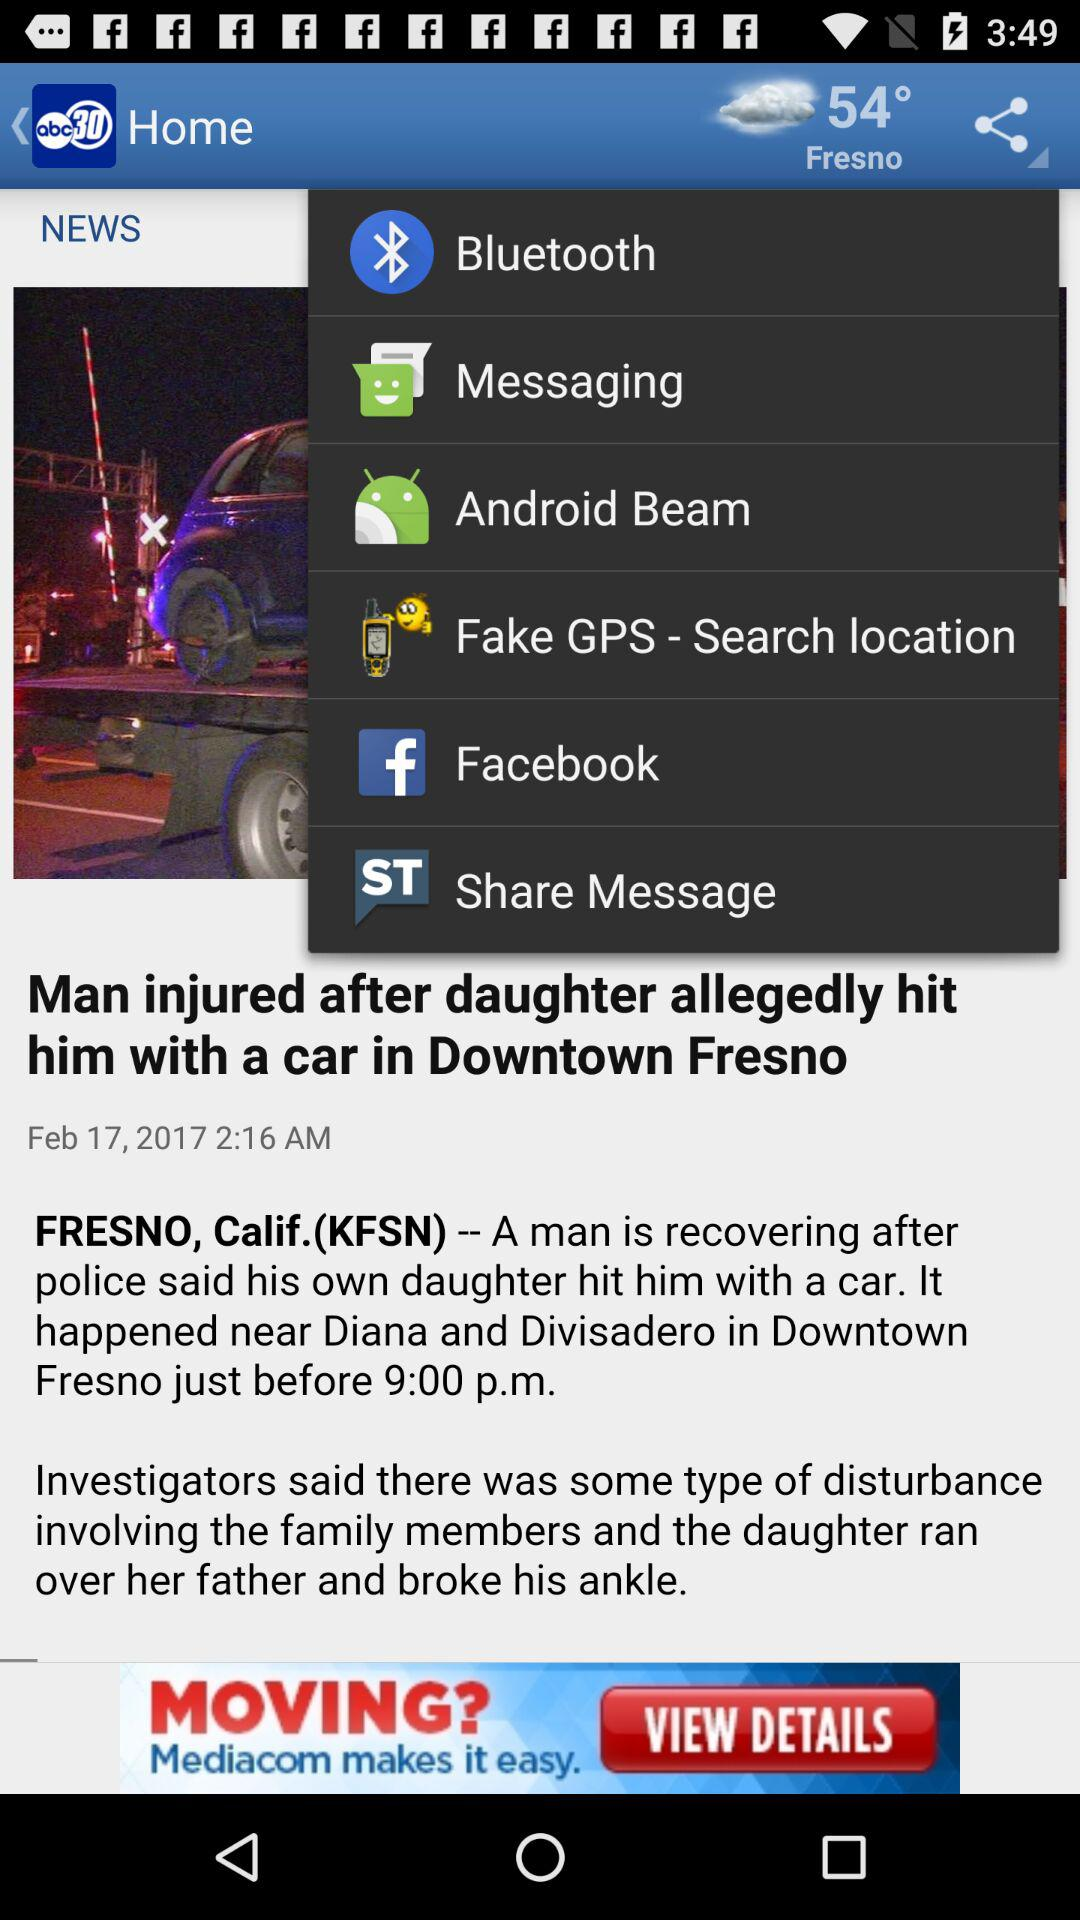What is the temperature? The temperature is 54°. 